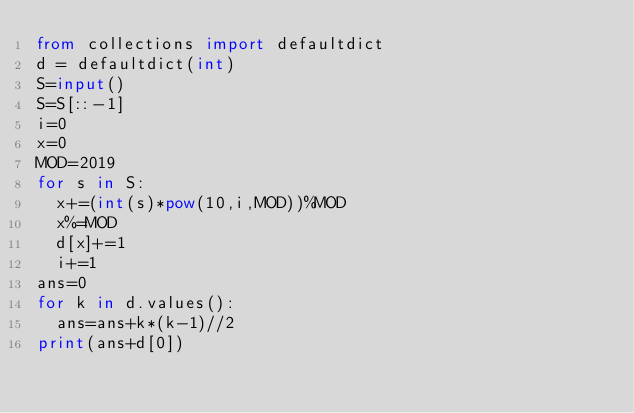Convert code to text. <code><loc_0><loc_0><loc_500><loc_500><_Python_>from collections import defaultdict
d = defaultdict(int)
S=input()
S=S[::-1]
i=0
x=0
MOD=2019
for s in S:
  x+=(int(s)*pow(10,i,MOD))%MOD
  x%=MOD
  d[x]+=1
  i+=1
ans=0
for k in d.values():
  ans=ans+k*(k-1)//2
print(ans+d[0])
</code> 